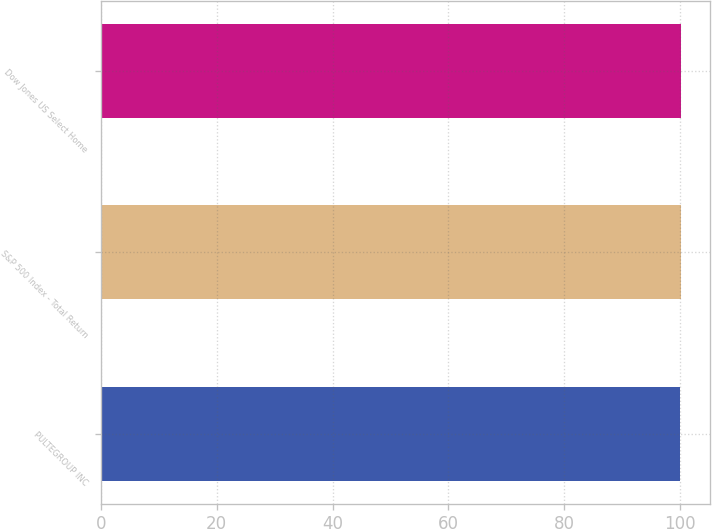Convert chart. <chart><loc_0><loc_0><loc_500><loc_500><bar_chart><fcel>PULTEGROUP INC<fcel>S&P 500 Index - Total Return<fcel>Dow Jones US Select Home<nl><fcel>100<fcel>100.1<fcel>100.2<nl></chart> 